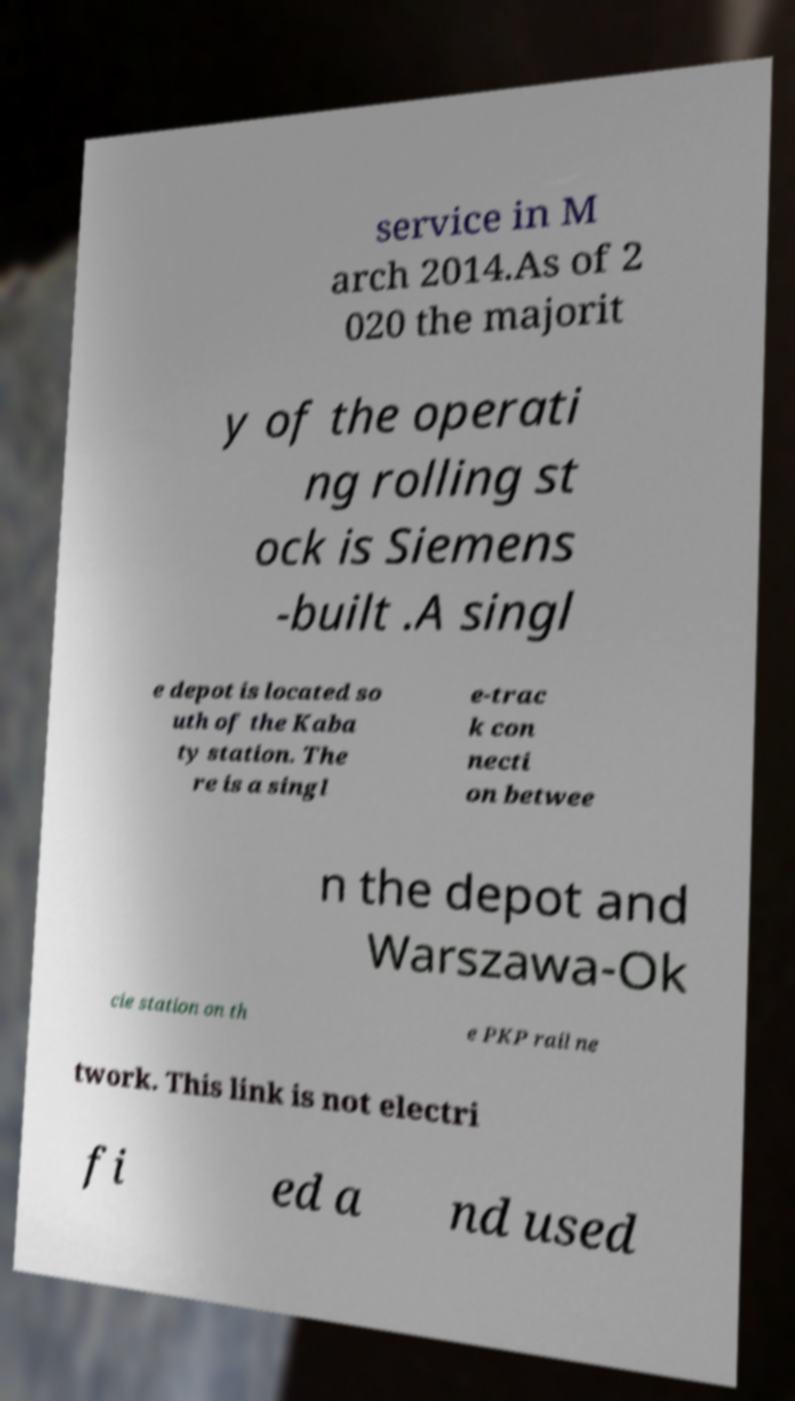Please identify and transcribe the text found in this image. service in M arch 2014.As of 2 020 the majorit y of the operati ng rolling st ock is Siemens -built .A singl e depot is located so uth of the Kaba ty station. The re is a singl e-trac k con necti on betwee n the depot and Warszawa-Ok cie station on th e PKP rail ne twork. This link is not electri fi ed a nd used 